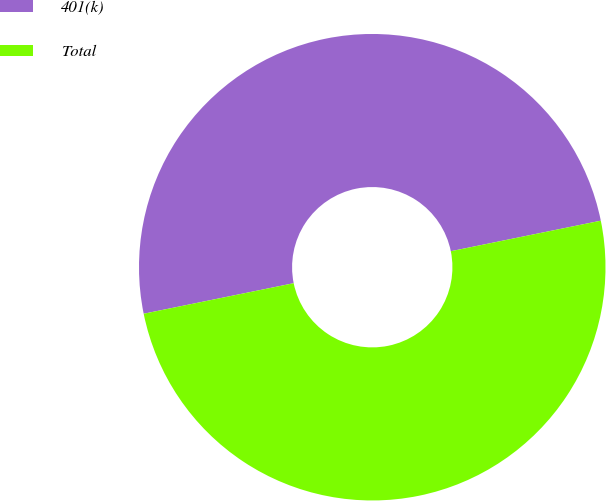Convert chart to OTSL. <chart><loc_0><loc_0><loc_500><loc_500><pie_chart><fcel>401(k)<fcel>Total<nl><fcel>50.0%<fcel>50.0%<nl></chart> 